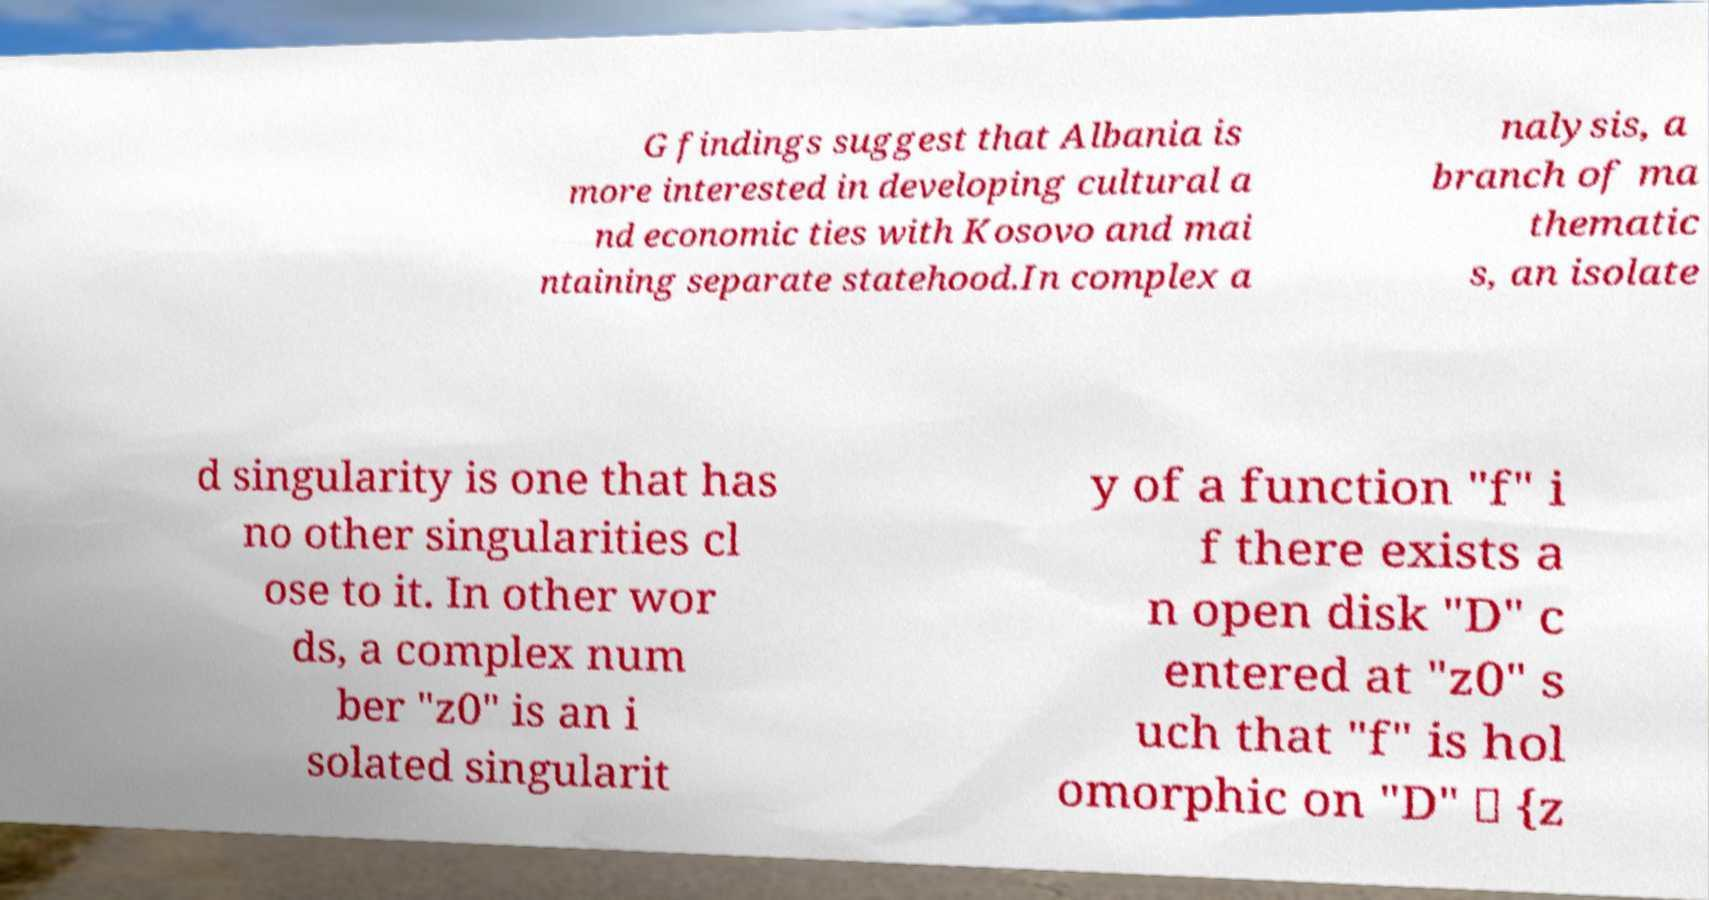Could you assist in decoding the text presented in this image and type it out clearly? G findings suggest that Albania is more interested in developing cultural a nd economic ties with Kosovo and mai ntaining separate statehood.In complex a nalysis, a branch of ma thematic s, an isolate d singularity is one that has no other singularities cl ose to it. In other wor ds, a complex num ber "z0" is an i solated singularit y of a function "f" i f there exists a n open disk "D" c entered at "z0" s uch that "f" is hol omorphic on "D" \ {z 